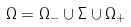<formula> <loc_0><loc_0><loc_500><loc_500>\Omega = \Omega _ { - } \cup \Sigma \cup \Omega _ { + }</formula> 